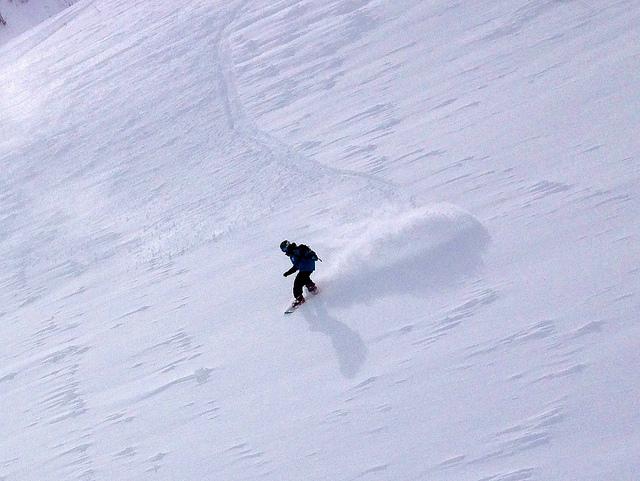Are there pine trees?
Be succinct. No. What is the man doing?
Concise answer only. Snowboarding. Is he on a hill?
Short answer required. Yes. What is the person doing?
Concise answer only. Snowboarding. 